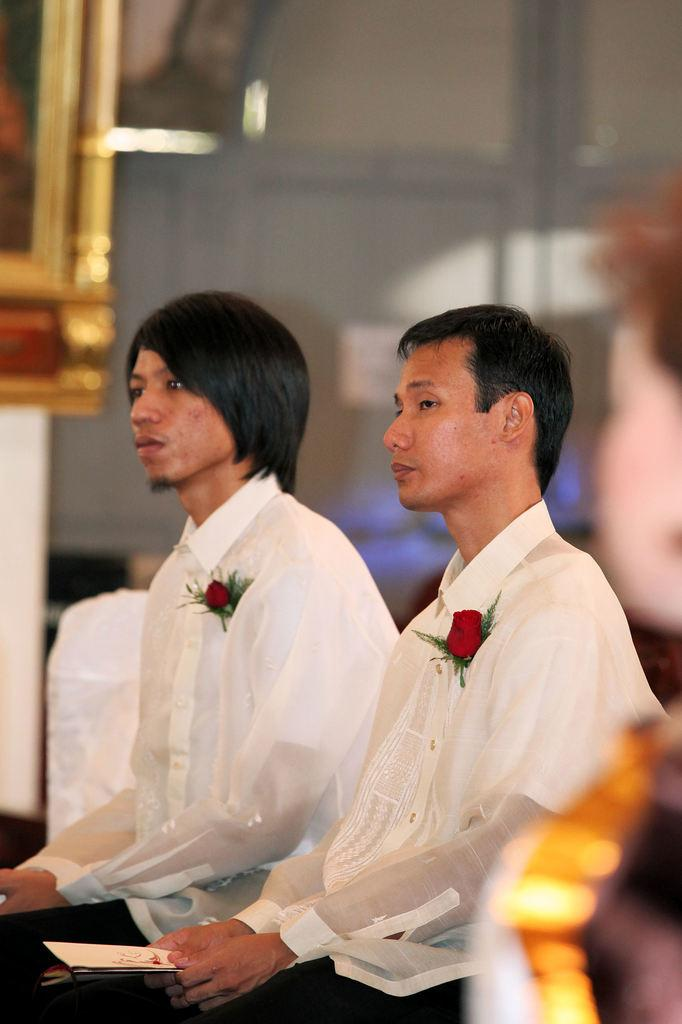How many people are in the image? There are three members in the image. What are the positions of two of the people in the image? Two of them are sitting in the middle of the image. Can you describe the background of the image? The background of the image is blurred. What scientific discovery is being celebrated in the image? There is no indication of a scientific discovery being celebrated in the image. Where is the image taken, and what place is depicted? The location of the image and the place depicted cannot be determined from the provided facts. 